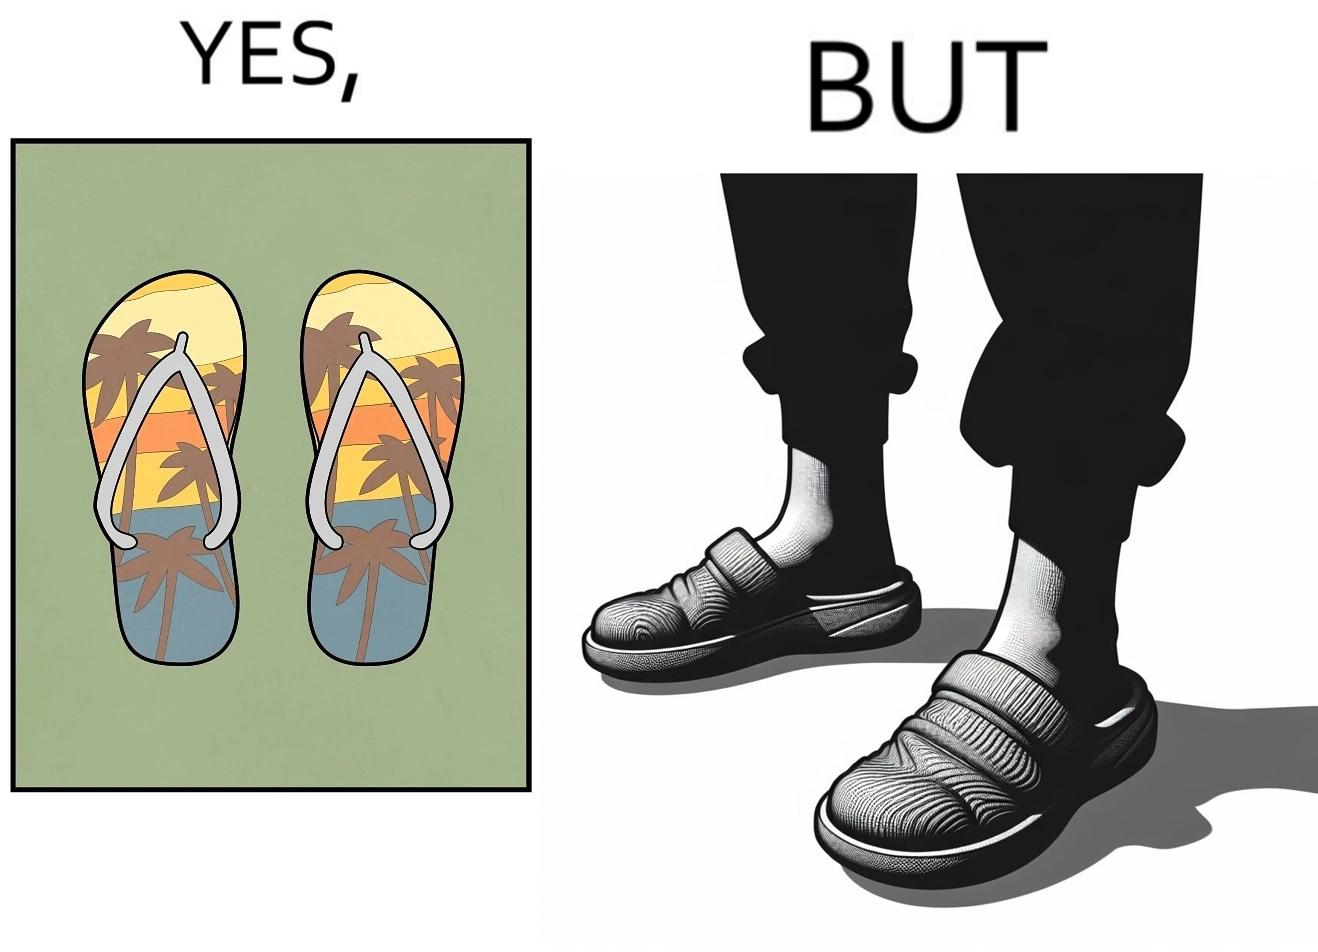Explain why this image is satirical. The image is ironical, as when a person wear a pair of slippers with a colorful image, it is almost completely hidden due to the legs of the person wearing the slippers, which counters the point of having such colorful slippers. 